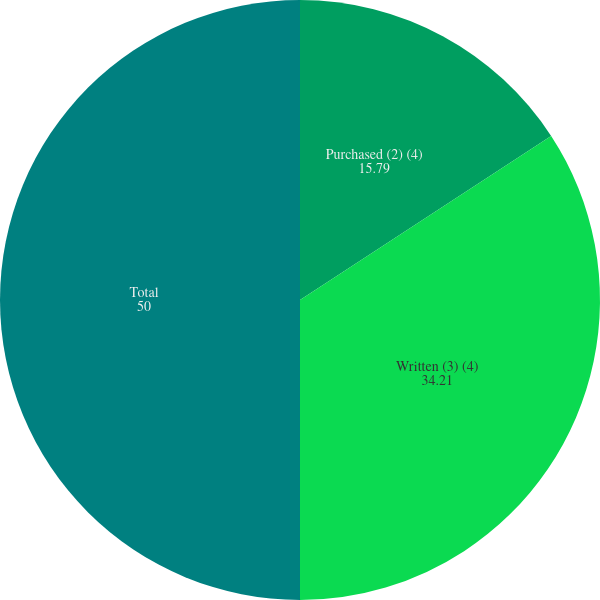Convert chart to OTSL. <chart><loc_0><loc_0><loc_500><loc_500><pie_chart><fcel>Purchased (2) (4)<fcel>Written (3) (4)<fcel>Total<nl><fcel>15.79%<fcel>34.21%<fcel>50.0%<nl></chart> 